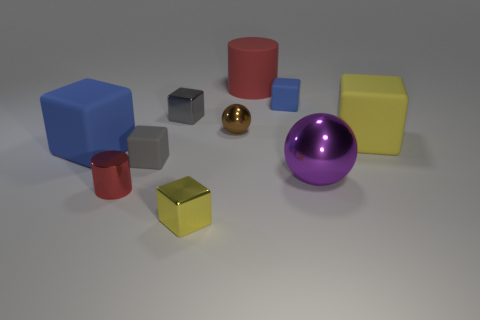How many tiny rubber objects are on the left side of the matte cylinder and behind the tiny gray matte object?
Give a very brief answer. 0. Do the yellow matte block and the rubber cube that is behind the big yellow matte object have the same size?
Your answer should be compact. No. There is a red thing in front of the metallic sphere behind the big purple thing to the right of the small brown ball; what size is it?
Keep it short and to the point. Small. What size is the red cylinder that is in front of the big shiny object?
Provide a short and direct response. Small. What is the shape of the gray object that is the same material as the purple thing?
Offer a very short reply. Cube. Is the material of the sphere that is left of the purple object the same as the large purple ball?
Your answer should be very brief. Yes. How many other things are there of the same material as the small red cylinder?
Your answer should be very brief. 4. How many things are yellow blocks that are behind the tiny yellow metallic thing or small matte cubes to the right of the tiny cylinder?
Offer a very short reply. 3. Is the shape of the yellow thing that is on the left side of the tiny brown shiny sphere the same as the red object right of the red metal object?
Your response must be concise. No. What shape is the blue thing that is the same size as the brown ball?
Provide a short and direct response. Cube. 